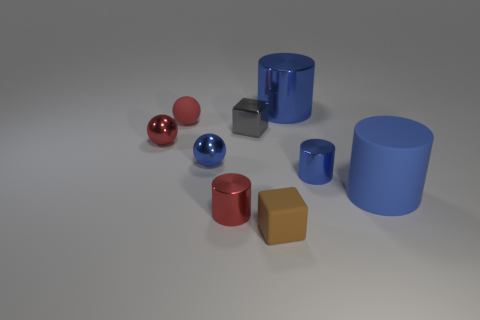What is the size of the shiny block?
Provide a short and direct response. Small. Is the number of large red shiny objects less than the number of red matte things?
Provide a short and direct response. Yes. How many other large objects have the same color as the big rubber object?
Offer a very short reply. 1. There is a tiny metal cylinder that is to the right of the small brown object; is its color the same as the tiny rubber ball?
Offer a very short reply. No. What is the shape of the tiny matte thing to the left of the tiny red cylinder?
Give a very brief answer. Sphere. Are there any gray objects that are behind the matte thing on the left side of the small gray metal cube?
Keep it short and to the point. No. How many brown cylinders have the same material as the gray block?
Provide a succinct answer. 0. There is a blue metallic object that is on the left side of the red object right of the blue shiny object on the left side of the small brown thing; what is its size?
Your answer should be compact. Small. What number of red objects are in front of the large matte cylinder?
Make the answer very short. 1. Are there more cylinders than matte objects?
Offer a terse response. Yes. 